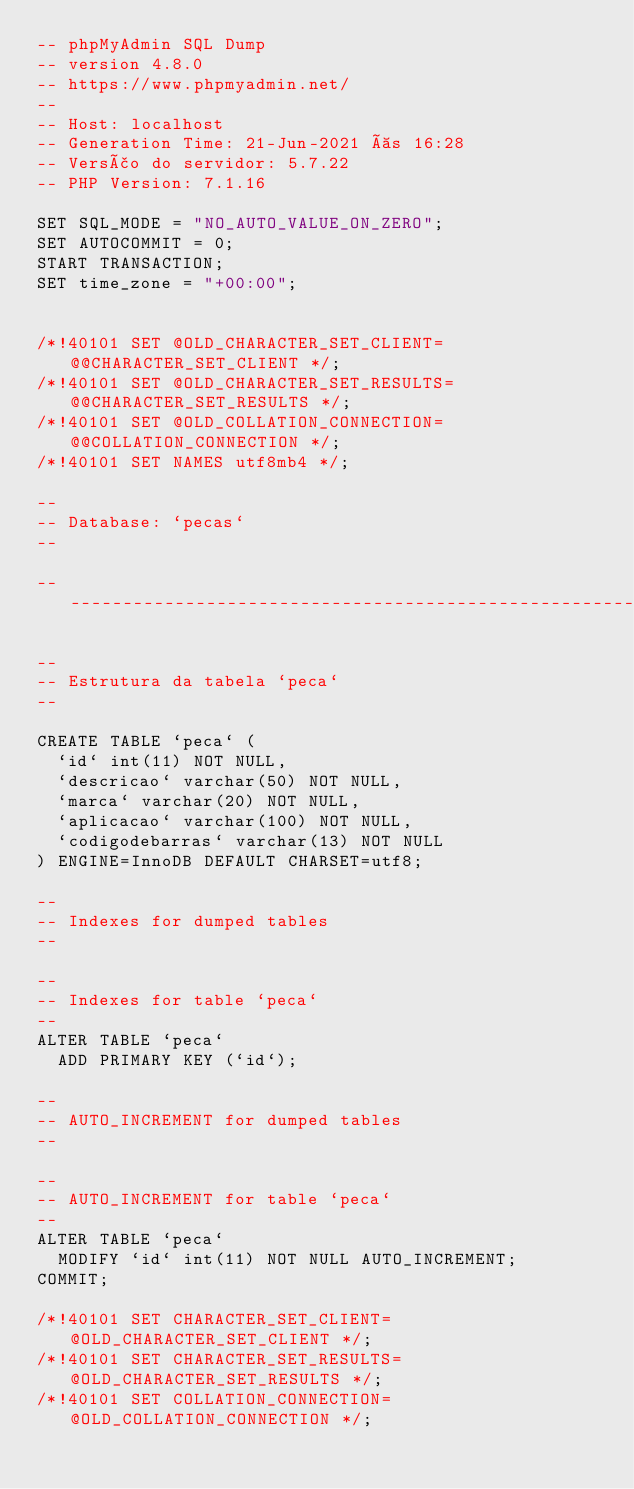Convert code to text. <code><loc_0><loc_0><loc_500><loc_500><_SQL_>-- phpMyAdmin SQL Dump
-- version 4.8.0
-- https://www.phpmyadmin.net/
--
-- Host: localhost
-- Generation Time: 21-Jun-2021 às 16:28
-- Versão do servidor: 5.7.22
-- PHP Version: 7.1.16

SET SQL_MODE = "NO_AUTO_VALUE_ON_ZERO";
SET AUTOCOMMIT = 0;
START TRANSACTION;
SET time_zone = "+00:00";


/*!40101 SET @OLD_CHARACTER_SET_CLIENT=@@CHARACTER_SET_CLIENT */;
/*!40101 SET @OLD_CHARACTER_SET_RESULTS=@@CHARACTER_SET_RESULTS */;
/*!40101 SET @OLD_COLLATION_CONNECTION=@@COLLATION_CONNECTION */;
/*!40101 SET NAMES utf8mb4 */;

--
-- Database: `pecas`
--

-- --------------------------------------------------------

--
-- Estrutura da tabela `peca`
--

CREATE TABLE `peca` (
  `id` int(11) NOT NULL,
  `descricao` varchar(50) NOT NULL,
  `marca` varchar(20) NOT NULL,
  `aplicacao` varchar(100) NOT NULL,
  `codigodebarras` varchar(13) NOT NULL
) ENGINE=InnoDB DEFAULT CHARSET=utf8;

--
-- Indexes for dumped tables
--

--
-- Indexes for table `peca`
--
ALTER TABLE `peca`
  ADD PRIMARY KEY (`id`);

--
-- AUTO_INCREMENT for dumped tables
--

--
-- AUTO_INCREMENT for table `peca`
--
ALTER TABLE `peca`
  MODIFY `id` int(11) NOT NULL AUTO_INCREMENT;
COMMIT;

/*!40101 SET CHARACTER_SET_CLIENT=@OLD_CHARACTER_SET_CLIENT */;
/*!40101 SET CHARACTER_SET_RESULTS=@OLD_CHARACTER_SET_RESULTS */;
/*!40101 SET COLLATION_CONNECTION=@OLD_COLLATION_CONNECTION */;
</code> 